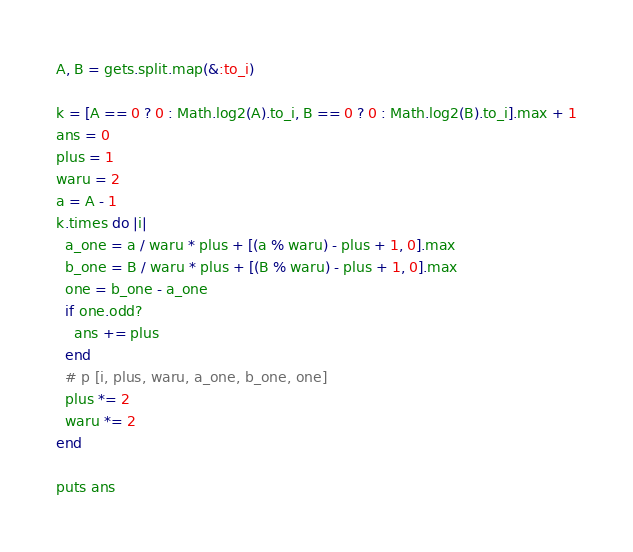<code> <loc_0><loc_0><loc_500><loc_500><_Ruby_>A, B = gets.split.map(&:to_i)

k = [A == 0 ? 0 : Math.log2(A).to_i, B == 0 ? 0 : Math.log2(B).to_i].max + 1
ans = 0
plus = 1
waru = 2
a = A - 1
k.times do |i|
  a_one = a / waru * plus + [(a % waru) - plus + 1, 0].max
  b_one = B / waru * plus + [(B % waru) - plus + 1, 0].max
  one = b_one - a_one
  if one.odd?
    ans += plus
  end
  # p [i, plus, waru, a_one, b_one, one]
  plus *= 2
  waru *= 2
end

puts ans
</code> 